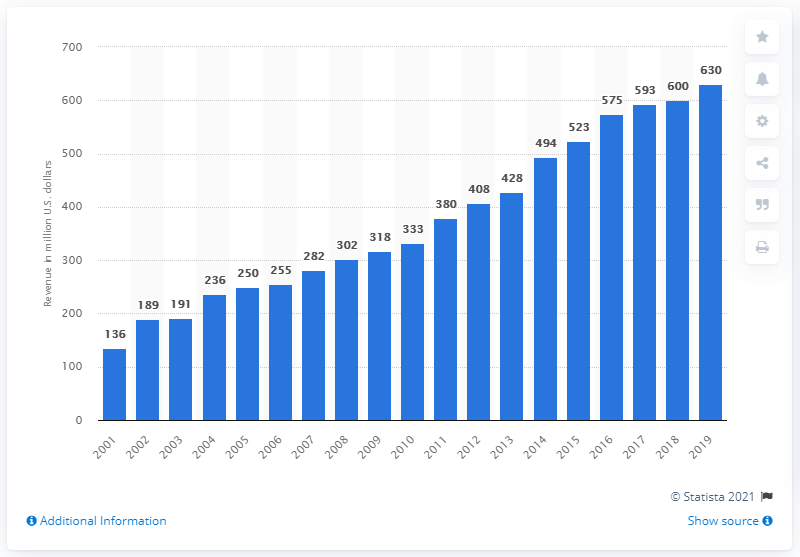Specify some key components in this picture. The New England Patriots made their first profits in the year 2001. In 2019, the New England Patriots generated approximately $630 million in revenue. 